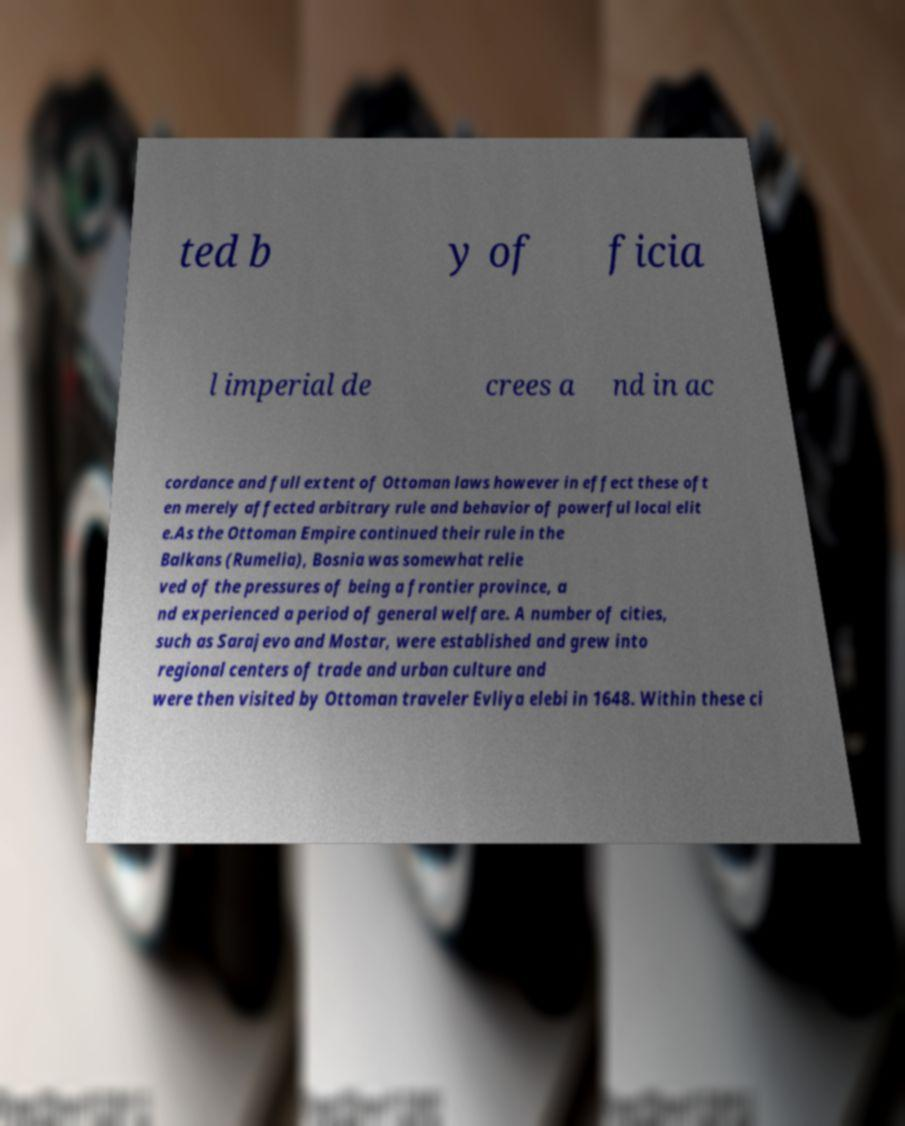What messages or text are displayed in this image? I need them in a readable, typed format. ted b y of ficia l imperial de crees a nd in ac cordance and full extent of Ottoman laws however in effect these oft en merely affected arbitrary rule and behavior of powerful local elit e.As the Ottoman Empire continued their rule in the Balkans (Rumelia), Bosnia was somewhat relie ved of the pressures of being a frontier province, a nd experienced a period of general welfare. A number of cities, such as Sarajevo and Mostar, were established and grew into regional centers of trade and urban culture and were then visited by Ottoman traveler Evliya elebi in 1648. Within these ci 